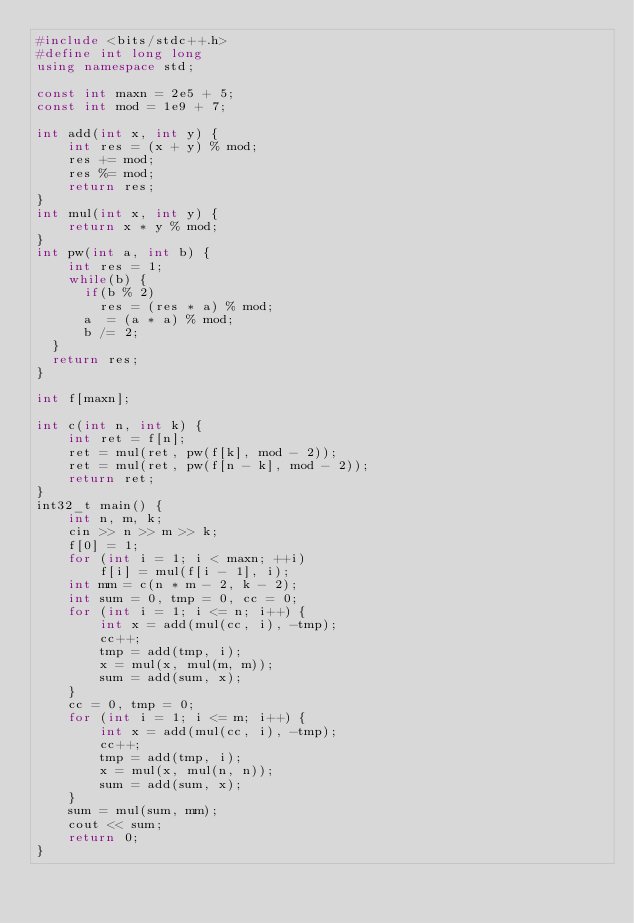<code> <loc_0><loc_0><loc_500><loc_500><_C++_>#include <bits/stdc++.h>
#define int long long
using namespace std;

const int maxn = 2e5 + 5;
const int mod = 1e9 + 7;
 
int add(int x, int y) {
    int res = (x + y) % mod;
    res += mod;
    res %= mod;
    return res;
}
int mul(int x, int y) {
    return x * y % mod;
}
int pw(int a, int b) {
    int res = 1;
    while(b) {
    	if(b % 2)
    		res = (res * a) % mod;
    	a  = (a * a) % mod;
    	b /= 2;
	}
	return res;
}

int f[maxn];

int c(int n, int k) {
    int ret = f[n];
    ret = mul(ret, pw(f[k], mod - 2));
    ret = mul(ret, pw(f[n - k], mod - 2));
    return ret;
}
int32_t main() {
    int n, m, k;
    cin >> n >> m >> k;
    f[0] = 1;
    for (int i = 1; i < maxn; ++i)
        f[i] = mul(f[i - 1], i);
    int mm = c(n * m - 2, k - 2);
    int sum = 0, tmp = 0, cc = 0;
    for (int i = 1; i <= n; i++) {
        int x = add(mul(cc, i), -tmp);
        cc++;
        tmp = add(tmp, i);
        x = mul(x, mul(m, m));
        sum = add(sum, x);
    }
    cc = 0, tmp = 0;
    for (int i = 1; i <= m; i++) {
        int x = add(mul(cc, i), -tmp);
        cc++;
        tmp = add(tmp, i);
        x = mul(x, mul(n, n));
        sum = add(sum, x);
    }
    sum = mul(sum, mm);
    cout << sum;
    return 0;
}</code> 